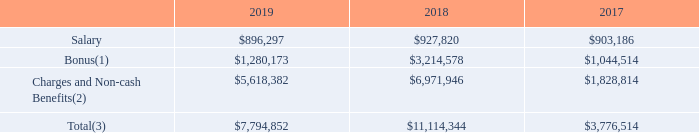(1)  The bonus paid in 2019, 2018 and 2017 was approved by the compensation Committee and Supervisory Board with respect to the 2018, 2017 and 2016 financial year, respectively, based on the evaluation and assessment of the actual fulfillment of a number of pre-defined objectives for such year.
(2)  Including stock awards, employer social contributions, company car allowance, pension contributions, complementary pension contributions, miscellaneous allowances as well as one-off contractually obligated deferred compensation paid to Mr. Bozotti in 2019.
In accordance with the resolutions adopted at our AGM held on May 30, 2012, the bonus of our former President and Chief Executive Officer, Mr. Bozotti, in 2018 and 2017 included a portion of a bonus payable in stock awards and corresponding to 86,782 and 59,435 vested shares, respectively, based on fulfillment of a number of pre-defined objectives.
In addition, our sole member of our Managing Board, President and Chief Executive Officer, Mr. Chery, was granted, in accordance with the compensation policy adopted by our General Meeting of Shareholders and subsequent shareholder authorizations, up to 100,000 unvested Stock Awards. The vesting of such stock awards is conditional upon the sole member of our Managing Board, President and Chief Executive Officer’s, continued service with us.
(3) In 2019, the total compensation of the sole member of our Managing Board, President and Chief Executive Officer was 46% fixed to 54% variable, compared to 12% fixed to 88% variable in 2018 and 44% fixed to 56% variable in 2017.
What is approving authority of paid bonus? The bonus paid in 2019, 2018 and 2017 was approved by the compensation committee and supervisory board. What was the total compensation of the sole member of our Managing Board, President and Chief Executive Officer in 2019? 46% fixed to 54% variable. What was the total compensation of the sole member of our Managing Board, President and Chief Executive Officer in 2018? 12% fixed to 88% variable. What is the increase/ (decrease) in Salary from the period 2017 to 2018? 927,820-903,186
Answer: 24634. What is the increase/ (decrease) in Bonus from the period 2017 to 2018? 3,214,578-1,044,514
Answer: 2170064. What is the increase/ (decrease) in Charges and Non-cash Benefits from the period 2017 to 2018? 6,971,946-1,828,814
Answer: 5143132. 